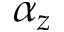Convert formula to latex. <formula><loc_0><loc_0><loc_500><loc_500>\alpha _ { z }</formula> 